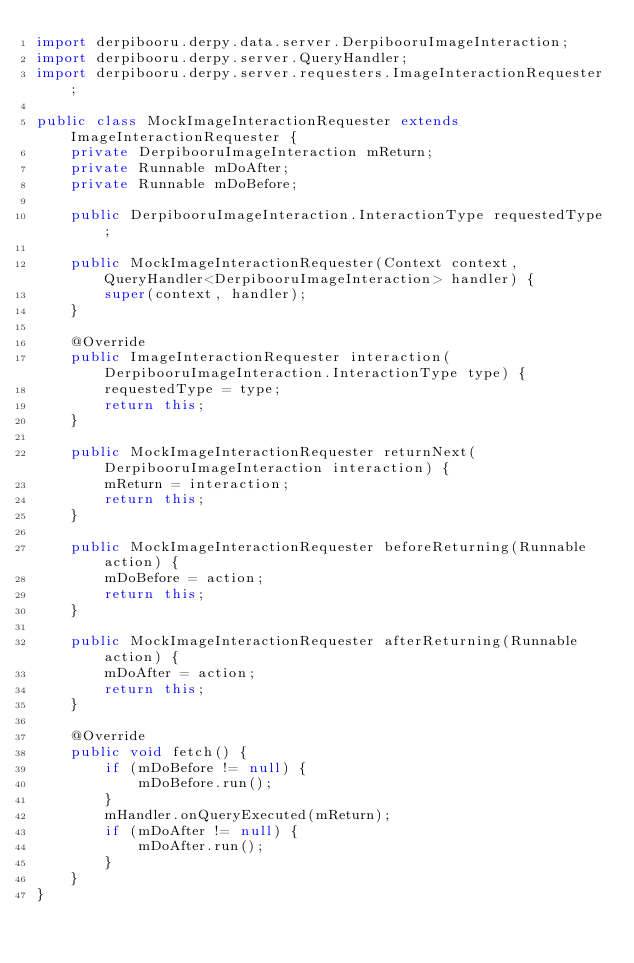Convert code to text. <code><loc_0><loc_0><loc_500><loc_500><_Java_>import derpibooru.derpy.data.server.DerpibooruImageInteraction;
import derpibooru.derpy.server.QueryHandler;
import derpibooru.derpy.server.requesters.ImageInteractionRequester;

public class MockImageInteractionRequester extends ImageInteractionRequester {
    private DerpibooruImageInteraction mReturn;
    private Runnable mDoAfter;
    private Runnable mDoBefore;

    public DerpibooruImageInteraction.InteractionType requestedType;

    public MockImageInteractionRequester(Context context, QueryHandler<DerpibooruImageInteraction> handler) {
        super(context, handler);
    }

    @Override
    public ImageInteractionRequester interaction(DerpibooruImageInteraction.InteractionType type) {
        requestedType = type;
        return this;
    }

    public MockImageInteractionRequester returnNext(DerpibooruImageInteraction interaction) {
        mReturn = interaction;
        return this;
    }

    public MockImageInteractionRequester beforeReturning(Runnable action) {
        mDoBefore = action;
        return this;
    }

    public MockImageInteractionRequester afterReturning(Runnable action) {
        mDoAfter = action;
        return this;
    }

    @Override
    public void fetch() {
        if (mDoBefore != null) {
            mDoBefore.run();
        }
        mHandler.onQueryExecuted(mReturn);
        if (mDoAfter != null) {
            mDoAfter.run();
        }
    }
}
</code> 